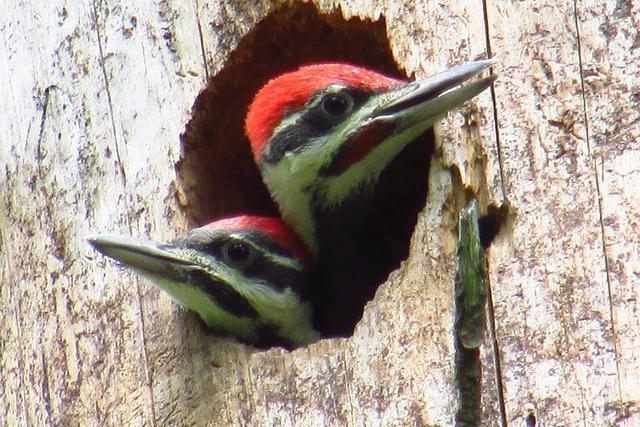How many animals are in the image?
Give a very brief answer. 2. How many birds are in the picture?
Give a very brief answer. 2. How many vases are empty?
Give a very brief answer. 0. 